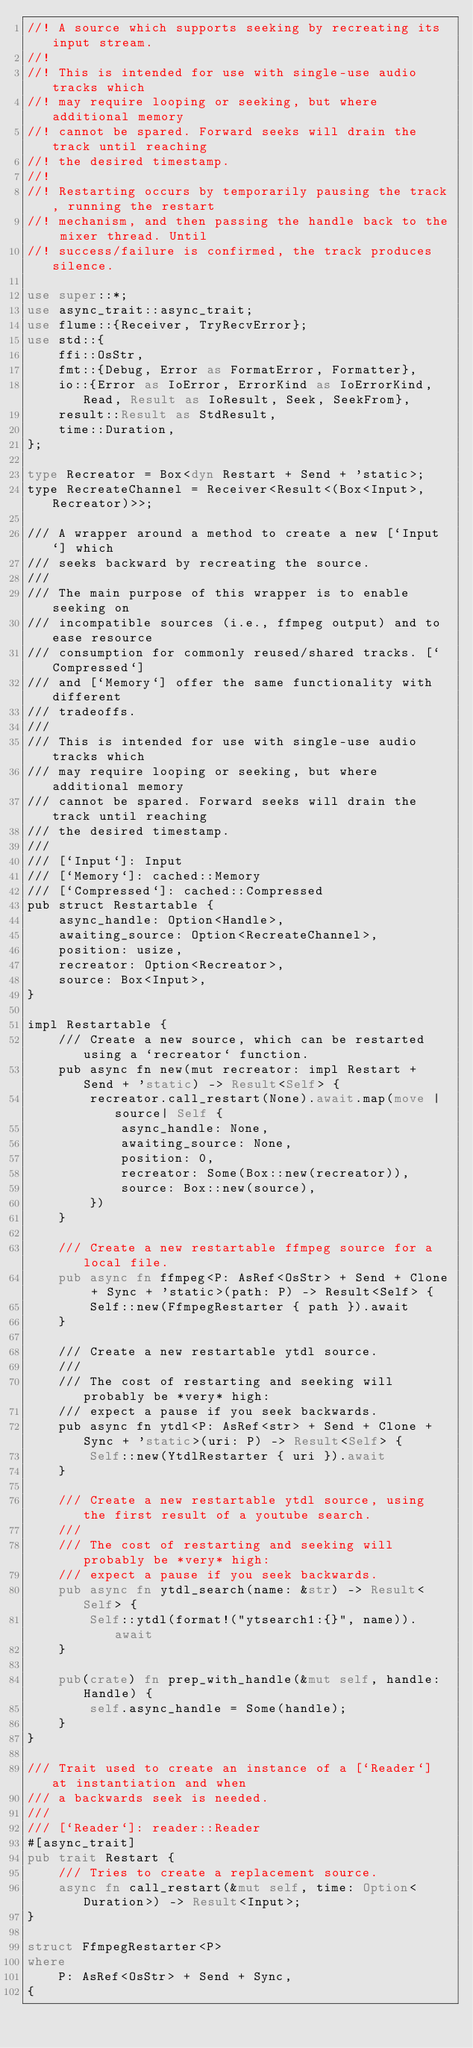Convert code to text. <code><loc_0><loc_0><loc_500><loc_500><_Rust_>//! A source which supports seeking by recreating its input stream.
//!
//! This is intended for use with single-use audio tracks which
//! may require looping or seeking, but where additional memory
//! cannot be spared. Forward seeks will drain the track until reaching
//! the desired timestamp.
//!
//! Restarting occurs by temporarily pausing the track, running the restart
//! mechanism, and then passing the handle back to the mixer thread. Until
//! success/failure is confirmed, the track produces silence.

use super::*;
use async_trait::async_trait;
use flume::{Receiver, TryRecvError};
use std::{
    ffi::OsStr,
    fmt::{Debug, Error as FormatError, Formatter},
    io::{Error as IoError, ErrorKind as IoErrorKind, Read, Result as IoResult, Seek, SeekFrom},
    result::Result as StdResult,
    time::Duration,
};

type Recreator = Box<dyn Restart + Send + 'static>;
type RecreateChannel = Receiver<Result<(Box<Input>, Recreator)>>;

/// A wrapper around a method to create a new [`Input`] which
/// seeks backward by recreating the source.
///
/// The main purpose of this wrapper is to enable seeking on
/// incompatible sources (i.e., ffmpeg output) and to ease resource
/// consumption for commonly reused/shared tracks. [`Compressed`]
/// and [`Memory`] offer the same functionality with different
/// tradeoffs.
///
/// This is intended for use with single-use audio tracks which
/// may require looping or seeking, but where additional memory
/// cannot be spared. Forward seeks will drain the track until reaching
/// the desired timestamp.
///
/// [`Input`]: Input
/// [`Memory`]: cached::Memory
/// [`Compressed`]: cached::Compressed
pub struct Restartable {
    async_handle: Option<Handle>,
    awaiting_source: Option<RecreateChannel>,
    position: usize,
    recreator: Option<Recreator>,
    source: Box<Input>,
}

impl Restartable {
    /// Create a new source, which can be restarted using a `recreator` function.
    pub async fn new(mut recreator: impl Restart + Send + 'static) -> Result<Self> {
        recreator.call_restart(None).await.map(move |source| Self {
            async_handle: None,
            awaiting_source: None,
            position: 0,
            recreator: Some(Box::new(recreator)),
            source: Box::new(source),
        })
    }

    /// Create a new restartable ffmpeg source for a local file.
    pub async fn ffmpeg<P: AsRef<OsStr> + Send + Clone + Sync + 'static>(path: P) -> Result<Self> {
        Self::new(FfmpegRestarter { path }).await
    }

    /// Create a new restartable ytdl source.
    ///
    /// The cost of restarting and seeking will probably be *very* high:
    /// expect a pause if you seek backwards.
    pub async fn ytdl<P: AsRef<str> + Send + Clone + Sync + 'static>(uri: P) -> Result<Self> {
        Self::new(YtdlRestarter { uri }).await
    }

    /// Create a new restartable ytdl source, using the first result of a youtube search.
    ///
    /// The cost of restarting and seeking will probably be *very* high:
    /// expect a pause if you seek backwards.
    pub async fn ytdl_search(name: &str) -> Result<Self> {
        Self::ytdl(format!("ytsearch1:{}", name)).await
    }

    pub(crate) fn prep_with_handle(&mut self, handle: Handle) {
        self.async_handle = Some(handle);
    }
}

/// Trait used to create an instance of a [`Reader`] at instantiation and when
/// a backwards seek is needed.
///
/// [`Reader`]: reader::Reader
#[async_trait]
pub trait Restart {
    /// Tries to create a replacement source.
    async fn call_restart(&mut self, time: Option<Duration>) -> Result<Input>;
}

struct FfmpegRestarter<P>
where
    P: AsRef<OsStr> + Send + Sync,
{</code> 